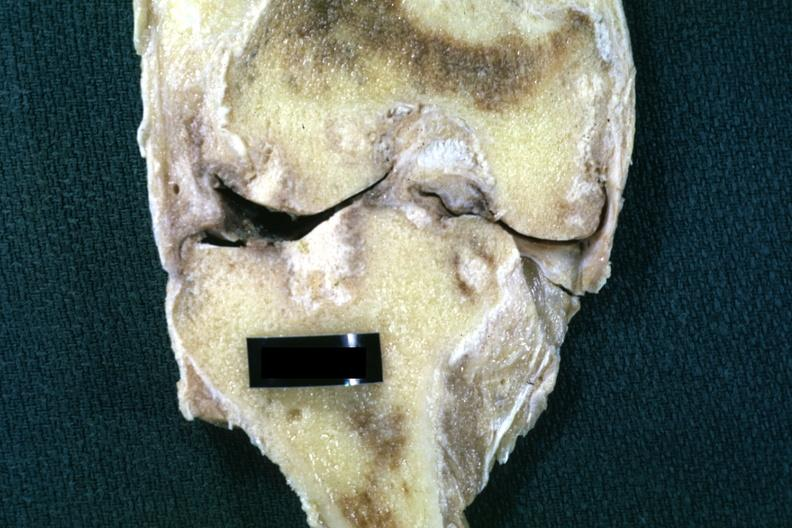what does this image show?
Answer the question using a single word or phrase. Fixed tissue frontal section of joint with obvious cartilage loss and subsynovial fibrosis and synovial fibrosis 